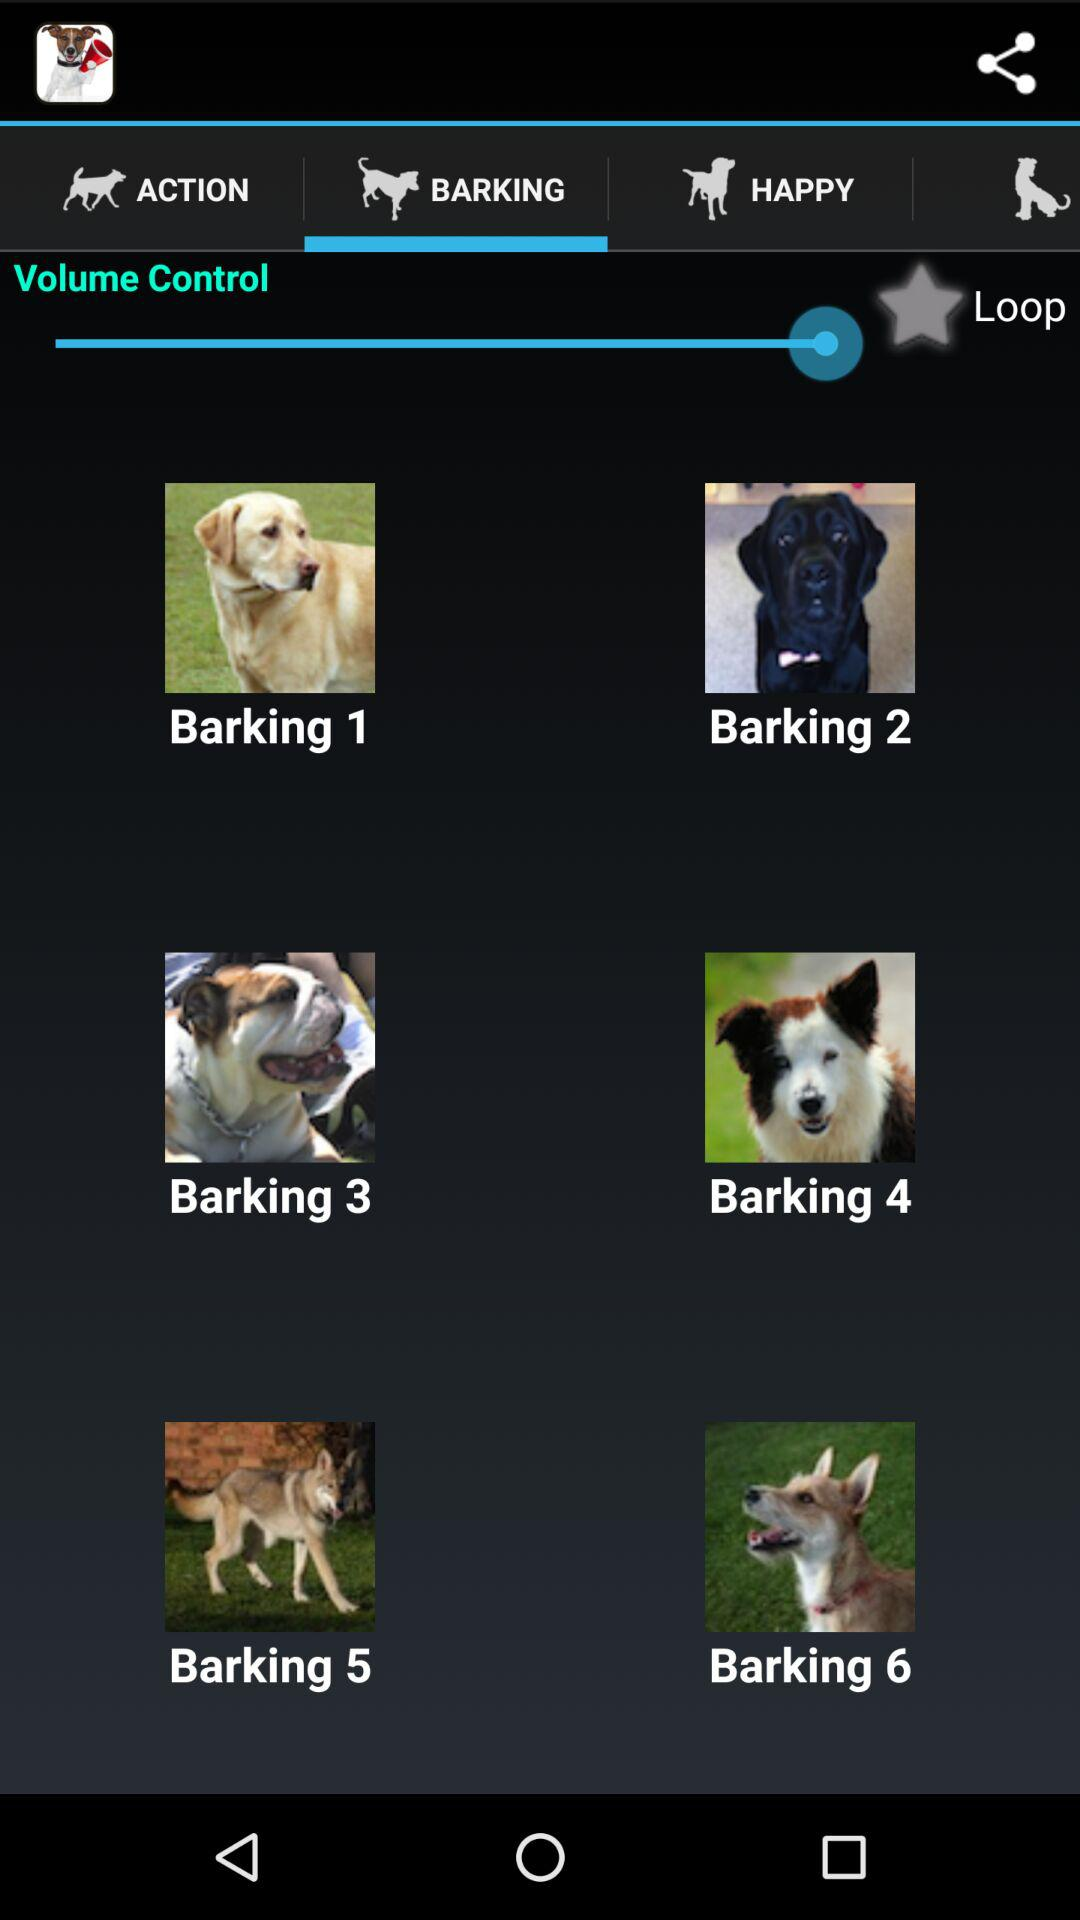Which tab is selected? The selected tab is "BARKING". 